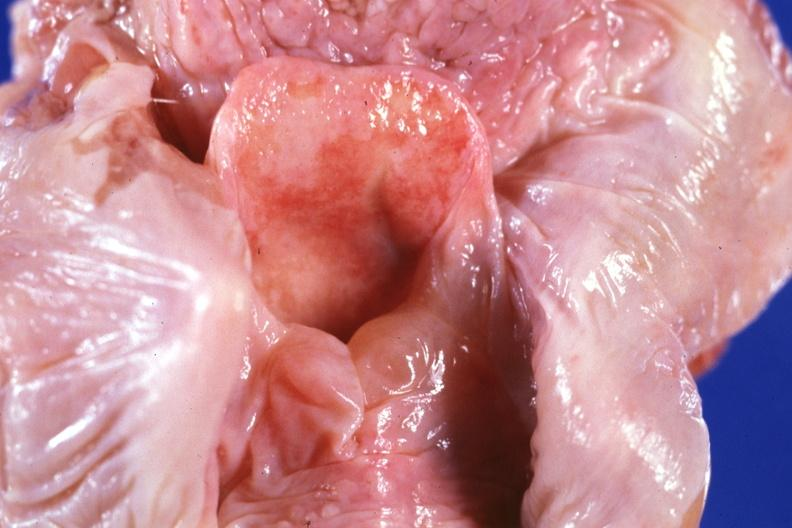does this image show unopened larynx seen from above edema really is in hypopharynx?
Answer the question using a single word or phrase. Yes 